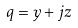<formula> <loc_0><loc_0><loc_500><loc_500>q = y + j z</formula> 